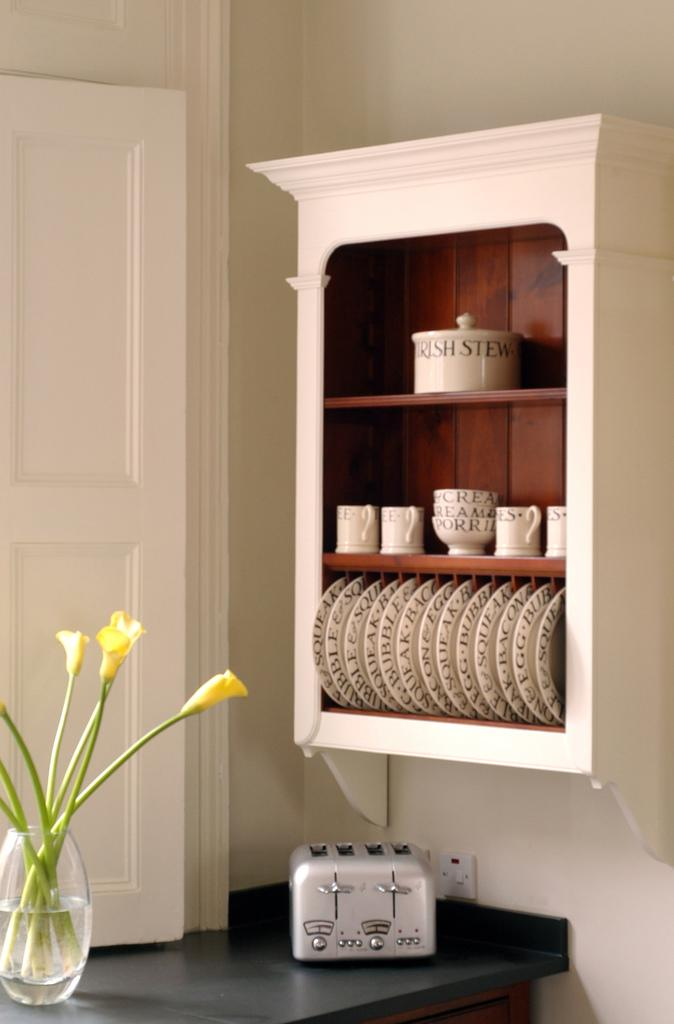<image>
Present a compact description of the photo's key features. A pot on a shelf has the words Irish stew on it. 